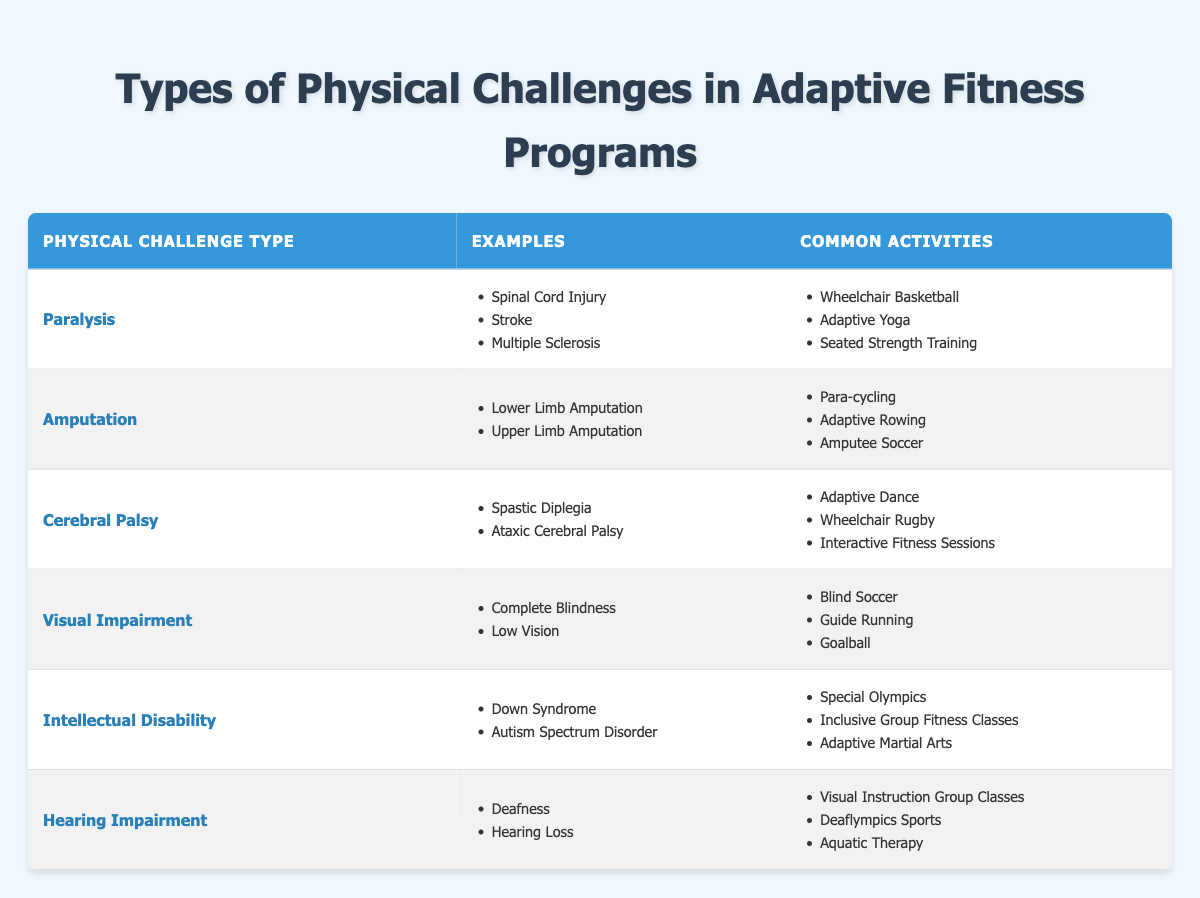What common activities are associated with paralysis? Paralysis is listed in the table with associated common activities. By checking the "Common Activities" column for "Paralysis," we find three activities: Wheelchair Basketball, Adaptive Yoga, and Seated Strength Training.
Answer: Wheelchair Basketball, Adaptive Yoga, Seated Strength Training Is "Goalball" a common activity for individuals with visual impairment? The table specifies the common activities for each physical challenge type. In the row for "Visual Impairment," "Goalball" is included as one of the activities. Hence, the answer is yes.
Answer: Yes How many different physical challenge types are listed in the table? The table provides six rows of data, each representing a distinct physical challenge type: Paralysis, Amputation, Cerebral Palsy, Visual Impairment, Intellectual Disability, and Hearing Impairment. Therefore, there are six types.
Answer: 6 Which physical challenge type has examples related to "autism spectrum disorder"? From the table, we look for the physical challenge types with examples listed. In the row for "Intellectual Disability," "Autism Spectrum Disorder" is mentioned. Thus, the answer is Intellectual Disability.
Answer: Intellectual Disability What is the sum of the common activities for both Amputation and Visual Impairment? The "Common Activities" for "Amputation" include Para-cycling, Adaptive Rowing, and Amputee Soccer (3 activities), and for "Visual Impairment," we also count Blind Soccer, Guide Running, and Goalball (3 activities). Adding them gives us a total of 3 + 3 = 6.
Answer: 6 Does anyone with hearing loss participate in the Special Olympics? The table does not list "Special Olympics" under the common activities for "Hearing Impairment," but it is associated with "Intellectual Disability" instead. This suggests it is not a common activity for those with hearing loss.
Answer: No Which physical challenge type features adaptive dance as a common activity? According to the table, "Adaptive Dance" is listed under the common activities for "Cerebral Palsy." By checking that row, we find it specifically mentioned there.
Answer: Cerebral Palsy How many examples of paralysis-related conditions are there in the table? For the physical challenge type "Paralysis," the examples listed include Spinal Cord Injury, Stroke, and Multiple Sclerosis. By counting these, we see there are three examples.
Answer: 3 